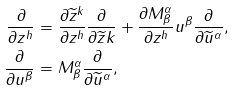Convert formula to latex. <formula><loc_0><loc_0><loc_500><loc_500>\frac { \partial } { \partial z ^ { h } } & = \frac { \partial \widetilde { z } ^ { k } } { \partial z ^ { h } } \frac { \partial } { \partial \widetilde { z } k } + \frac { \partial M _ { \beta } ^ { \alpha } } { \partial z ^ { h } } u ^ { \beta } \frac { \partial } { \partial \widetilde { u } ^ { \alpha } } , \\ \frac { \partial } { \partial u ^ { \beta } } & = M _ { \beta } ^ { \alpha } \frac { \partial } { \partial \widetilde { u } ^ { \alpha } } ,</formula> 